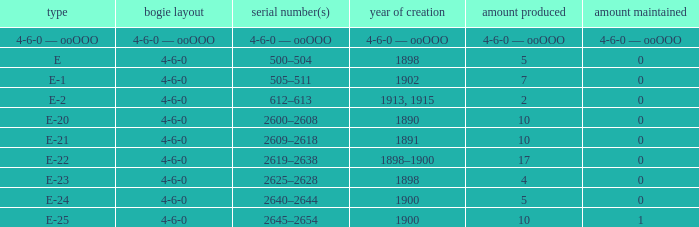What is the quantity preserved of the e-1 class? 0.0. 